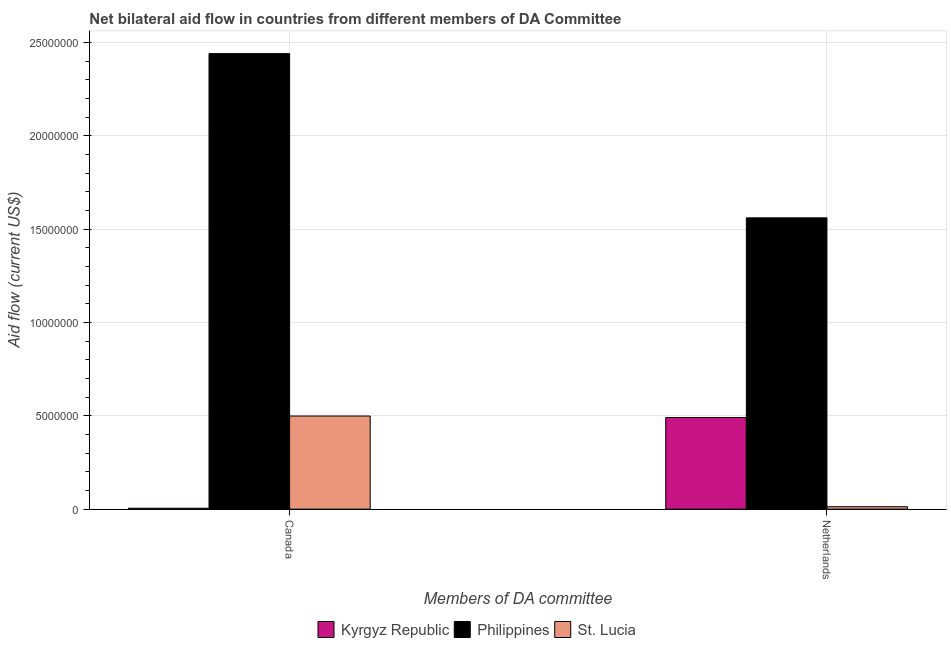How many different coloured bars are there?
Provide a short and direct response. 3. How many bars are there on the 2nd tick from the left?
Your response must be concise. 3. How many bars are there on the 1st tick from the right?
Offer a terse response. 3. What is the label of the 2nd group of bars from the left?
Your response must be concise. Netherlands. What is the amount of aid given by netherlands in St. Lucia?
Your answer should be very brief. 1.30e+05. Across all countries, what is the maximum amount of aid given by netherlands?
Make the answer very short. 1.56e+07. Across all countries, what is the minimum amount of aid given by netherlands?
Make the answer very short. 1.30e+05. In which country was the amount of aid given by netherlands maximum?
Your answer should be very brief. Philippines. In which country was the amount of aid given by netherlands minimum?
Give a very brief answer. St. Lucia. What is the total amount of aid given by netherlands in the graph?
Make the answer very short. 2.06e+07. What is the difference between the amount of aid given by netherlands in St. Lucia and that in Kyrgyz Republic?
Give a very brief answer. -4.78e+06. What is the difference between the amount of aid given by netherlands in Kyrgyz Republic and the amount of aid given by canada in St. Lucia?
Offer a very short reply. -8.00e+04. What is the average amount of aid given by canada per country?
Provide a succinct answer. 9.82e+06. What is the difference between the amount of aid given by netherlands and amount of aid given by canada in Kyrgyz Republic?
Keep it short and to the point. 4.86e+06. What is the ratio of the amount of aid given by netherlands in Philippines to that in St. Lucia?
Your answer should be very brief. 120.08. What does the 3rd bar from the left in Canada represents?
Offer a terse response. St. Lucia. What does the 1st bar from the right in Netherlands represents?
Your answer should be compact. St. Lucia. How many bars are there?
Keep it short and to the point. 6. What is the difference between two consecutive major ticks on the Y-axis?
Provide a short and direct response. 5.00e+06. How many legend labels are there?
Offer a very short reply. 3. What is the title of the graph?
Your response must be concise. Net bilateral aid flow in countries from different members of DA Committee. Does "France" appear as one of the legend labels in the graph?
Ensure brevity in your answer.  No. What is the label or title of the X-axis?
Provide a short and direct response. Members of DA committee. What is the Aid flow (current US$) of Kyrgyz Republic in Canada?
Offer a terse response. 5.00e+04. What is the Aid flow (current US$) of Philippines in Canada?
Your answer should be compact. 2.44e+07. What is the Aid flow (current US$) in St. Lucia in Canada?
Give a very brief answer. 4.99e+06. What is the Aid flow (current US$) in Kyrgyz Republic in Netherlands?
Offer a very short reply. 4.91e+06. What is the Aid flow (current US$) in Philippines in Netherlands?
Ensure brevity in your answer.  1.56e+07. What is the Aid flow (current US$) of St. Lucia in Netherlands?
Make the answer very short. 1.30e+05. Across all Members of DA committee, what is the maximum Aid flow (current US$) in Kyrgyz Republic?
Your response must be concise. 4.91e+06. Across all Members of DA committee, what is the maximum Aid flow (current US$) in Philippines?
Your response must be concise. 2.44e+07. Across all Members of DA committee, what is the maximum Aid flow (current US$) in St. Lucia?
Your answer should be compact. 4.99e+06. Across all Members of DA committee, what is the minimum Aid flow (current US$) in Philippines?
Give a very brief answer. 1.56e+07. What is the total Aid flow (current US$) in Kyrgyz Republic in the graph?
Offer a terse response. 4.96e+06. What is the total Aid flow (current US$) in Philippines in the graph?
Your response must be concise. 4.00e+07. What is the total Aid flow (current US$) of St. Lucia in the graph?
Ensure brevity in your answer.  5.12e+06. What is the difference between the Aid flow (current US$) in Kyrgyz Republic in Canada and that in Netherlands?
Offer a very short reply. -4.86e+06. What is the difference between the Aid flow (current US$) of Philippines in Canada and that in Netherlands?
Give a very brief answer. 8.80e+06. What is the difference between the Aid flow (current US$) of St. Lucia in Canada and that in Netherlands?
Offer a terse response. 4.86e+06. What is the difference between the Aid flow (current US$) in Kyrgyz Republic in Canada and the Aid flow (current US$) in Philippines in Netherlands?
Your answer should be very brief. -1.56e+07. What is the difference between the Aid flow (current US$) of Kyrgyz Republic in Canada and the Aid flow (current US$) of St. Lucia in Netherlands?
Your response must be concise. -8.00e+04. What is the difference between the Aid flow (current US$) of Philippines in Canada and the Aid flow (current US$) of St. Lucia in Netherlands?
Your answer should be very brief. 2.43e+07. What is the average Aid flow (current US$) in Kyrgyz Republic per Members of DA committee?
Your answer should be very brief. 2.48e+06. What is the average Aid flow (current US$) of Philippines per Members of DA committee?
Give a very brief answer. 2.00e+07. What is the average Aid flow (current US$) of St. Lucia per Members of DA committee?
Your answer should be compact. 2.56e+06. What is the difference between the Aid flow (current US$) in Kyrgyz Republic and Aid flow (current US$) in Philippines in Canada?
Your response must be concise. -2.44e+07. What is the difference between the Aid flow (current US$) of Kyrgyz Republic and Aid flow (current US$) of St. Lucia in Canada?
Your response must be concise. -4.94e+06. What is the difference between the Aid flow (current US$) of Philippines and Aid flow (current US$) of St. Lucia in Canada?
Provide a succinct answer. 1.94e+07. What is the difference between the Aid flow (current US$) of Kyrgyz Republic and Aid flow (current US$) of Philippines in Netherlands?
Offer a terse response. -1.07e+07. What is the difference between the Aid flow (current US$) of Kyrgyz Republic and Aid flow (current US$) of St. Lucia in Netherlands?
Your response must be concise. 4.78e+06. What is the difference between the Aid flow (current US$) in Philippines and Aid flow (current US$) in St. Lucia in Netherlands?
Make the answer very short. 1.55e+07. What is the ratio of the Aid flow (current US$) of Kyrgyz Republic in Canada to that in Netherlands?
Ensure brevity in your answer.  0.01. What is the ratio of the Aid flow (current US$) in Philippines in Canada to that in Netherlands?
Offer a terse response. 1.56. What is the ratio of the Aid flow (current US$) in St. Lucia in Canada to that in Netherlands?
Offer a very short reply. 38.38. What is the difference between the highest and the second highest Aid flow (current US$) of Kyrgyz Republic?
Make the answer very short. 4.86e+06. What is the difference between the highest and the second highest Aid flow (current US$) in Philippines?
Provide a short and direct response. 8.80e+06. What is the difference between the highest and the second highest Aid flow (current US$) of St. Lucia?
Provide a succinct answer. 4.86e+06. What is the difference between the highest and the lowest Aid flow (current US$) in Kyrgyz Republic?
Make the answer very short. 4.86e+06. What is the difference between the highest and the lowest Aid flow (current US$) of Philippines?
Provide a succinct answer. 8.80e+06. What is the difference between the highest and the lowest Aid flow (current US$) in St. Lucia?
Keep it short and to the point. 4.86e+06. 